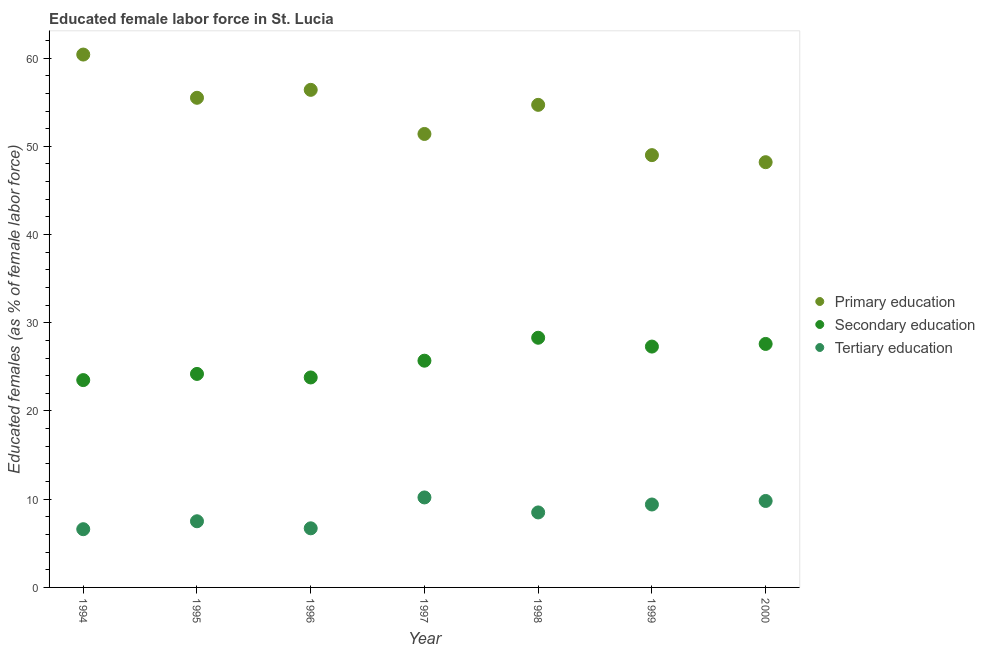How many different coloured dotlines are there?
Keep it short and to the point. 3. Across all years, what is the maximum percentage of female labor force who received secondary education?
Keep it short and to the point. 28.3. Across all years, what is the minimum percentage of female labor force who received secondary education?
Give a very brief answer. 23.5. In which year was the percentage of female labor force who received tertiary education maximum?
Provide a succinct answer. 1997. In which year was the percentage of female labor force who received secondary education minimum?
Your answer should be compact. 1994. What is the total percentage of female labor force who received secondary education in the graph?
Give a very brief answer. 180.4. What is the difference between the percentage of female labor force who received primary education in 1994 and that in 1995?
Offer a very short reply. 4.9. What is the difference between the percentage of female labor force who received secondary education in 1994 and the percentage of female labor force who received primary education in 1998?
Offer a terse response. -31.2. What is the average percentage of female labor force who received primary education per year?
Your response must be concise. 53.66. In the year 1995, what is the difference between the percentage of female labor force who received tertiary education and percentage of female labor force who received primary education?
Your response must be concise. -48. In how many years, is the percentage of female labor force who received tertiary education greater than 48 %?
Provide a short and direct response. 0. What is the ratio of the percentage of female labor force who received tertiary education in 1996 to that in 1998?
Provide a short and direct response. 0.79. Is the difference between the percentage of female labor force who received secondary education in 1995 and 1996 greater than the difference between the percentage of female labor force who received tertiary education in 1995 and 1996?
Give a very brief answer. No. What is the difference between the highest and the second highest percentage of female labor force who received primary education?
Your response must be concise. 4. What is the difference between the highest and the lowest percentage of female labor force who received tertiary education?
Provide a short and direct response. 3.6. In how many years, is the percentage of female labor force who received primary education greater than the average percentage of female labor force who received primary education taken over all years?
Keep it short and to the point. 4. How many years are there in the graph?
Provide a short and direct response. 7. What is the difference between two consecutive major ticks on the Y-axis?
Your answer should be very brief. 10. Are the values on the major ticks of Y-axis written in scientific E-notation?
Ensure brevity in your answer.  No. Does the graph contain any zero values?
Provide a succinct answer. No. Where does the legend appear in the graph?
Offer a very short reply. Center right. What is the title of the graph?
Give a very brief answer. Educated female labor force in St. Lucia. Does "Renewable sources" appear as one of the legend labels in the graph?
Ensure brevity in your answer.  No. What is the label or title of the Y-axis?
Your answer should be compact. Educated females (as % of female labor force). What is the Educated females (as % of female labor force) in Primary education in 1994?
Your answer should be very brief. 60.4. What is the Educated females (as % of female labor force) of Secondary education in 1994?
Keep it short and to the point. 23.5. What is the Educated females (as % of female labor force) of Tertiary education in 1994?
Provide a succinct answer. 6.6. What is the Educated females (as % of female labor force) in Primary education in 1995?
Your answer should be compact. 55.5. What is the Educated females (as % of female labor force) of Secondary education in 1995?
Offer a terse response. 24.2. What is the Educated females (as % of female labor force) of Tertiary education in 1995?
Ensure brevity in your answer.  7.5. What is the Educated females (as % of female labor force) in Primary education in 1996?
Your answer should be very brief. 56.4. What is the Educated females (as % of female labor force) of Secondary education in 1996?
Provide a short and direct response. 23.8. What is the Educated females (as % of female labor force) in Tertiary education in 1996?
Keep it short and to the point. 6.7. What is the Educated females (as % of female labor force) of Primary education in 1997?
Your response must be concise. 51.4. What is the Educated females (as % of female labor force) of Secondary education in 1997?
Provide a short and direct response. 25.7. What is the Educated females (as % of female labor force) in Tertiary education in 1997?
Offer a very short reply. 10.2. What is the Educated females (as % of female labor force) in Primary education in 1998?
Make the answer very short. 54.7. What is the Educated females (as % of female labor force) in Secondary education in 1998?
Offer a very short reply. 28.3. What is the Educated females (as % of female labor force) of Tertiary education in 1998?
Make the answer very short. 8.5. What is the Educated females (as % of female labor force) of Secondary education in 1999?
Provide a short and direct response. 27.3. What is the Educated females (as % of female labor force) of Tertiary education in 1999?
Offer a terse response. 9.4. What is the Educated females (as % of female labor force) of Primary education in 2000?
Keep it short and to the point. 48.2. What is the Educated females (as % of female labor force) of Secondary education in 2000?
Ensure brevity in your answer.  27.6. What is the Educated females (as % of female labor force) of Tertiary education in 2000?
Keep it short and to the point. 9.8. Across all years, what is the maximum Educated females (as % of female labor force) of Primary education?
Ensure brevity in your answer.  60.4. Across all years, what is the maximum Educated females (as % of female labor force) in Secondary education?
Ensure brevity in your answer.  28.3. Across all years, what is the maximum Educated females (as % of female labor force) in Tertiary education?
Ensure brevity in your answer.  10.2. Across all years, what is the minimum Educated females (as % of female labor force) in Primary education?
Keep it short and to the point. 48.2. Across all years, what is the minimum Educated females (as % of female labor force) in Tertiary education?
Offer a very short reply. 6.6. What is the total Educated females (as % of female labor force) of Primary education in the graph?
Ensure brevity in your answer.  375.6. What is the total Educated females (as % of female labor force) of Secondary education in the graph?
Give a very brief answer. 180.4. What is the total Educated females (as % of female labor force) of Tertiary education in the graph?
Keep it short and to the point. 58.7. What is the difference between the Educated females (as % of female labor force) of Tertiary education in 1994 and that in 1995?
Make the answer very short. -0.9. What is the difference between the Educated females (as % of female labor force) in Tertiary education in 1994 and that in 1996?
Keep it short and to the point. -0.1. What is the difference between the Educated females (as % of female labor force) in Tertiary education in 1994 and that in 1997?
Keep it short and to the point. -3.6. What is the difference between the Educated females (as % of female labor force) in Secondary education in 1994 and that in 1998?
Your answer should be very brief. -4.8. What is the difference between the Educated females (as % of female labor force) in Primary education in 1994 and that in 2000?
Your answer should be compact. 12.2. What is the difference between the Educated females (as % of female labor force) in Secondary education in 1994 and that in 2000?
Provide a short and direct response. -4.1. What is the difference between the Educated females (as % of female labor force) in Tertiary education in 1994 and that in 2000?
Make the answer very short. -3.2. What is the difference between the Educated females (as % of female labor force) in Tertiary education in 1995 and that in 1996?
Keep it short and to the point. 0.8. What is the difference between the Educated females (as % of female labor force) of Primary education in 1995 and that in 1997?
Make the answer very short. 4.1. What is the difference between the Educated females (as % of female labor force) of Primary education in 1995 and that in 1998?
Provide a short and direct response. 0.8. What is the difference between the Educated females (as % of female labor force) in Secondary education in 1995 and that in 1998?
Make the answer very short. -4.1. What is the difference between the Educated females (as % of female labor force) in Secondary education in 1995 and that in 1999?
Provide a succinct answer. -3.1. What is the difference between the Educated females (as % of female labor force) in Tertiary education in 1995 and that in 1999?
Offer a very short reply. -1.9. What is the difference between the Educated females (as % of female labor force) in Primary education in 1995 and that in 2000?
Offer a very short reply. 7.3. What is the difference between the Educated females (as % of female labor force) in Secondary education in 1996 and that in 1997?
Keep it short and to the point. -1.9. What is the difference between the Educated females (as % of female labor force) of Primary education in 1996 and that in 1998?
Offer a very short reply. 1.7. What is the difference between the Educated females (as % of female labor force) of Tertiary education in 1996 and that in 1998?
Give a very brief answer. -1.8. What is the difference between the Educated females (as % of female labor force) in Primary education in 1996 and that in 1999?
Ensure brevity in your answer.  7.4. What is the difference between the Educated females (as % of female labor force) in Secondary education in 1996 and that in 1999?
Keep it short and to the point. -3.5. What is the difference between the Educated females (as % of female labor force) of Tertiary education in 1996 and that in 1999?
Keep it short and to the point. -2.7. What is the difference between the Educated females (as % of female labor force) of Tertiary education in 1996 and that in 2000?
Your response must be concise. -3.1. What is the difference between the Educated females (as % of female labor force) of Primary education in 1997 and that in 1999?
Provide a succinct answer. 2.4. What is the difference between the Educated females (as % of female labor force) of Tertiary education in 1997 and that in 1999?
Offer a terse response. 0.8. What is the difference between the Educated females (as % of female labor force) in Primary education in 1997 and that in 2000?
Give a very brief answer. 3.2. What is the difference between the Educated females (as % of female labor force) in Secondary education in 1997 and that in 2000?
Make the answer very short. -1.9. What is the difference between the Educated females (as % of female labor force) of Primary education in 1998 and that in 1999?
Provide a short and direct response. 5.7. What is the difference between the Educated females (as % of female labor force) of Secondary education in 1998 and that in 2000?
Provide a succinct answer. 0.7. What is the difference between the Educated females (as % of female labor force) of Secondary education in 1999 and that in 2000?
Your answer should be very brief. -0.3. What is the difference between the Educated females (as % of female labor force) in Tertiary education in 1999 and that in 2000?
Keep it short and to the point. -0.4. What is the difference between the Educated females (as % of female labor force) in Primary education in 1994 and the Educated females (as % of female labor force) in Secondary education in 1995?
Offer a terse response. 36.2. What is the difference between the Educated females (as % of female labor force) in Primary education in 1994 and the Educated females (as % of female labor force) in Tertiary education in 1995?
Keep it short and to the point. 52.9. What is the difference between the Educated females (as % of female labor force) of Secondary education in 1994 and the Educated females (as % of female labor force) of Tertiary education in 1995?
Keep it short and to the point. 16. What is the difference between the Educated females (as % of female labor force) of Primary education in 1994 and the Educated females (as % of female labor force) of Secondary education in 1996?
Offer a terse response. 36.6. What is the difference between the Educated females (as % of female labor force) of Primary education in 1994 and the Educated females (as % of female labor force) of Tertiary education in 1996?
Provide a succinct answer. 53.7. What is the difference between the Educated females (as % of female labor force) of Primary education in 1994 and the Educated females (as % of female labor force) of Secondary education in 1997?
Provide a short and direct response. 34.7. What is the difference between the Educated females (as % of female labor force) in Primary education in 1994 and the Educated females (as % of female labor force) in Tertiary education in 1997?
Keep it short and to the point. 50.2. What is the difference between the Educated females (as % of female labor force) in Primary education in 1994 and the Educated females (as % of female labor force) in Secondary education in 1998?
Your answer should be compact. 32.1. What is the difference between the Educated females (as % of female labor force) of Primary education in 1994 and the Educated females (as % of female labor force) of Tertiary education in 1998?
Give a very brief answer. 51.9. What is the difference between the Educated females (as % of female labor force) of Secondary education in 1994 and the Educated females (as % of female labor force) of Tertiary education in 1998?
Offer a terse response. 15. What is the difference between the Educated females (as % of female labor force) in Primary education in 1994 and the Educated females (as % of female labor force) in Secondary education in 1999?
Keep it short and to the point. 33.1. What is the difference between the Educated females (as % of female labor force) in Primary education in 1994 and the Educated females (as % of female labor force) in Secondary education in 2000?
Offer a terse response. 32.8. What is the difference between the Educated females (as % of female labor force) of Primary education in 1994 and the Educated females (as % of female labor force) of Tertiary education in 2000?
Provide a succinct answer. 50.6. What is the difference between the Educated females (as % of female labor force) in Secondary education in 1994 and the Educated females (as % of female labor force) in Tertiary education in 2000?
Provide a succinct answer. 13.7. What is the difference between the Educated females (as % of female labor force) of Primary education in 1995 and the Educated females (as % of female labor force) of Secondary education in 1996?
Your answer should be compact. 31.7. What is the difference between the Educated females (as % of female labor force) in Primary education in 1995 and the Educated females (as % of female labor force) in Tertiary education in 1996?
Your response must be concise. 48.8. What is the difference between the Educated females (as % of female labor force) of Secondary education in 1995 and the Educated females (as % of female labor force) of Tertiary education in 1996?
Your answer should be very brief. 17.5. What is the difference between the Educated females (as % of female labor force) of Primary education in 1995 and the Educated females (as % of female labor force) of Secondary education in 1997?
Provide a short and direct response. 29.8. What is the difference between the Educated females (as % of female labor force) in Primary education in 1995 and the Educated females (as % of female labor force) in Tertiary education in 1997?
Give a very brief answer. 45.3. What is the difference between the Educated females (as % of female labor force) of Primary education in 1995 and the Educated females (as % of female labor force) of Secondary education in 1998?
Provide a short and direct response. 27.2. What is the difference between the Educated females (as % of female labor force) of Primary education in 1995 and the Educated females (as % of female labor force) of Tertiary education in 1998?
Keep it short and to the point. 47. What is the difference between the Educated females (as % of female labor force) in Secondary education in 1995 and the Educated females (as % of female labor force) in Tertiary education in 1998?
Your answer should be compact. 15.7. What is the difference between the Educated females (as % of female labor force) of Primary education in 1995 and the Educated females (as % of female labor force) of Secondary education in 1999?
Ensure brevity in your answer.  28.2. What is the difference between the Educated females (as % of female labor force) of Primary education in 1995 and the Educated females (as % of female labor force) of Tertiary education in 1999?
Offer a terse response. 46.1. What is the difference between the Educated females (as % of female labor force) of Secondary education in 1995 and the Educated females (as % of female labor force) of Tertiary education in 1999?
Keep it short and to the point. 14.8. What is the difference between the Educated females (as % of female labor force) of Primary education in 1995 and the Educated females (as % of female labor force) of Secondary education in 2000?
Ensure brevity in your answer.  27.9. What is the difference between the Educated females (as % of female labor force) in Primary education in 1995 and the Educated females (as % of female labor force) in Tertiary education in 2000?
Keep it short and to the point. 45.7. What is the difference between the Educated females (as % of female labor force) of Secondary education in 1995 and the Educated females (as % of female labor force) of Tertiary education in 2000?
Keep it short and to the point. 14.4. What is the difference between the Educated females (as % of female labor force) of Primary education in 1996 and the Educated females (as % of female labor force) of Secondary education in 1997?
Your answer should be very brief. 30.7. What is the difference between the Educated females (as % of female labor force) in Primary education in 1996 and the Educated females (as % of female labor force) in Tertiary education in 1997?
Make the answer very short. 46.2. What is the difference between the Educated females (as % of female labor force) of Secondary education in 1996 and the Educated females (as % of female labor force) of Tertiary education in 1997?
Provide a short and direct response. 13.6. What is the difference between the Educated females (as % of female labor force) in Primary education in 1996 and the Educated females (as % of female labor force) in Secondary education in 1998?
Ensure brevity in your answer.  28.1. What is the difference between the Educated females (as % of female labor force) of Primary education in 1996 and the Educated females (as % of female labor force) of Tertiary education in 1998?
Give a very brief answer. 47.9. What is the difference between the Educated females (as % of female labor force) of Primary education in 1996 and the Educated females (as % of female labor force) of Secondary education in 1999?
Offer a very short reply. 29.1. What is the difference between the Educated females (as % of female labor force) in Secondary education in 1996 and the Educated females (as % of female labor force) in Tertiary education in 1999?
Provide a short and direct response. 14.4. What is the difference between the Educated females (as % of female labor force) in Primary education in 1996 and the Educated females (as % of female labor force) in Secondary education in 2000?
Give a very brief answer. 28.8. What is the difference between the Educated females (as % of female labor force) of Primary education in 1996 and the Educated females (as % of female labor force) of Tertiary education in 2000?
Make the answer very short. 46.6. What is the difference between the Educated females (as % of female labor force) in Primary education in 1997 and the Educated females (as % of female labor force) in Secondary education in 1998?
Make the answer very short. 23.1. What is the difference between the Educated females (as % of female labor force) of Primary education in 1997 and the Educated females (as % of female labor force) of Tertiary education in 1998?
Provide a short and direct response. 42.9. What is the difference between the Educated females (as % of female labor force) in Secondary education in 1997 and the Educated females (as % of female labor force) in Tertiary education in 1998?
Ensure brevity in your answer.  17.2. What is the difference between the Educated females (as % of female labor force) in Primary education in 1997 and the Educated females (as % of female labor force) in Secondary education in 1999?
Keep it short and to the point. 24.1. What is the difference between the Educated females (as % of female labor force) of Primary education in 1997 and the Educated females (as % of female labor force) of Secondary education in 2000?
Your answer should be compact. 23.8. What is the difference between the Educated females (as % of female labor force) of Primary education in 1997 and the Educated females (as % of female labor force) of Tertiary education in 2000?
Provide a succinct answer. 41.6. What is the difference between the Educated females (as % of female labor force) of Secondary education in 1997 and the Educated females (as % of female labor force) of Tertiary education in 2000?
Your answer should be very brief. 15.9. What is the difference between the Educated females (as % of female labor force) in Primary education in 1998 and the Educated females (as % of female labor force) in Secondary education in 1999?
Your answer should be very brief. 27.4. What is the difference between the Educated females (as % of female labor force) of Primary education in 1998 and the Educated females (as % of female labor force) of Tertiary education in 1999?
Your response must be concise. 45.3. What is the difference between the Educated females (as % of female labor force) in Primary education in 1998 and the Educated females (as % of female labor force) in Secondary education in 2000?
Keep it short and to the point. 27.1. What is the difference between the Educated females (as % of female labor force) of Primary education in 1998 and the Educated females (as % of female labor force) of Tertiary education in 2000?
Your answer should be compact. 44.9. What is the difference between the Educated females (as % of female labor force) of Primary education in 1999 and the Educated females (as % of female labor force) of Secondary education in 2000?
Your answer should be very brief. 21.4. What is the difference between the Educated females (as % of female labor force) of Primary education in 1999 and the Educated females (as % of female labor force) of Tertiary education in 2000?
Keep it short and to the point. 39.2. What is the difference between the Educated females (as % of female labor force) of Secondary education in 1999 and the Educated females (as % of female labor force) of Tertiary education in 2000?
Give a very brief answer. 17.5. What is the average Educated females (as % of female labor force) of Primary education per year?
Provide a short and direct response. 53.66. What is the average Educated females (as % of female labor force) in Secondary education per year?
Your response must be concise. 25.77. What is the average Educated females (as % of female labor force) of Tertiary education per year?
Your answer should be very brief. 8.39. In the year 1994, what is the difference between the Educated females (as % of female labor force) in Primary education and Educated females (as % of female labor force) in Secondary education?
Your response must be concise. 36.9. In the year 1994, what is the difference between the Educated females (as % of female labor force) in Primary education and Educated females (as % of female labor force) in Tertiary education?
Offer a terse response. 53.8. In the year 1994, what is the difference between the Educated females (as % of female labor force) in Secondary education and Educated females (as % of female labor force) in Tertiary education?
Offer a terse response. 16.9. In the year 1995, what is the difference between the Educated females (as % of female labor force) of Primary education and Educated females (as % of female labor force) of Secondary education?
Your answer should be very brief. 31.3. In the year 1995, what is the difference between the Educated females (as % of female labor force) in Primary education and Educated females (as % of female labor force) in Tertiary education?
Your answer should be compact. 48. In the year 1996, what is the difference between the Educated females (as % of female labor force) in Primary education and Educated females (as % of female labor force) in Secondary education?
Your answer should be very brief. 32.6. In the year 1996, what is the difference between the Educated females (as % of female labor force) of Primary education and Educated females (as % of female labor force) of Tertiary education?
Keep it short and to the point. 49.7. In the year 1996, what is the difference between the Educated females (as % of female labor force) in Secondary education and Educated females (as % of female labor force) in Tertiary education?
Give a very brief answer. 17.1. In the year 1997, what is the difference between the Educated females (as % of female labor force) of Primary education and Educated females (as % of female labor force) of Secondary education?
Ensure brevity in your answer.  25.7. In the year 1997, what is the difference between the Educated females (as % of female labor force) in Primary education and Educated females (as % of female labor force) in Tertiary education?
Provide a short and direct response. 41.2. In the year 1997, what is the difference between the Educated females (as % of female labor force) in Secondary education and Educated females (as % of female labor force) in Tertiary education?
Keep it short and to the point. 15.5. In the year 1998, what is the difference between the Educated females (as % of female labor force) of Primary education and Educated females (as % of female labor force) of Secondary education?
Provide a succinct answer. 26.4. In the year 1998, what is the difference between the Educated females (as % of female labor force) in Primary education and Educated females (as % of female labor force) in Tertiary education?
Your answer should be very brief. 46.2. In the year 1998, what is the difference between the Educated females (as % of female labor force) in Secondary education and Educated females (as % of female labor force) in Tertiary education?
Ensure brevity in your answer.  19.8. In the year 1999, what is the difference between the Educated females (as % of female labor force) of Primary education and Educated females (as % of female labor force) of Secondary education?
Make the answer very short. 21.7. In the year 1999, what is the difference between the Educated females (as % of female labor force) in Primary education and Educated females (as % of female labor force) in Tertiary education?
Offer a terse response. 39.6. In the year 1999, what is the difference between the Educated females (as % of female labor force) of Secondary education and Educated females (as % of female labor force) of Tertiary education?
Your answer should be very brief. 17.9. In the year 2000, what is the difference between the Educated females (as % of female labor force) of Primary education and Educated females (as % of female labor force) of Secondary education?
Make the answer very short. 20.6. In the year 2000, what is the difference between the Educated females (as % of female labor force) of Primary education and Educated females (as % of female labor force) of Tertiary education?
Your answer should be very brief. 38.4. In the year 2000, what is the difference between the Educated females (as % of female labor force) of Secondary education and Educated females (as % of female labor force) of Tertiary education?
Your answer should be compact. 17.8. What is the ratio of the Educated females (as % of female labor force) in Primary education in 1994 to that in 1995?
Offer a very short reply. 1.09. What is the ratio of the Educated females (as % of female labor force) of Secondary education in 1994 to that in 1995?
Offer a terse response. 0.97. What is the ratio of the Educated females (as % of female labor force) in Tertiary education in 1994 to that in 1995?
Your answer should be very brief. 0.88. What is the ratio of the Educated females (as % of female labor force) of Primary education in 1994 to that in 1996?
Provide a succinct answer. 1.07. What is the ratio of the Educated females (as % of female labor force) in Secondary education in 1994 to that in 1996?
Provide a succinct answer. 0.99. What is the ratio of the Educated females (as % of female labor force) in Tertiary education in 1994 to that in 1996?
Make the answer very short. 0.99. What is the ratio of the Educated females (as % of female labor force) in Primary education in 1994 to that in 1997?
Your answer should be very brief. 1.18. What is the ratio of the Educated females (as % of female labor force) of Secondary education in 1994 to that in 1997?
Offer a very short reply. 0.91. What is the ratio of the Educated females (as % of female labor force) in Tertiary education in 1994 to that in 1997?
Your response must be concise. 0.65. What is the ratio of the Educated females (as % of female labor force) in Primary education in 1994 to that in 1998?
Ensure brevity in your answer.  1.1. What is the ratio of the Educated females (as % of female labor force) in Secondary education in 1994 to that in 1998?
Provide a short and direct response. 0.83. What is the ratio of the Educated females (as % of female labor force) in Tertiary education in 1994 to that in 1998?
Make the answer very short. 0.78. What is the ratio of the Educated females (as % of female labor force) of Primary education in 1994 to that in 1999?
Give a very brief answer. 1.23. What is the ratio of the Educated females (as % of female labor force) of Secondary education in 1994 to that in 1999?
Give a very brief answer. 0.86. What is the ratio of the Educated females (as % of female labor force) in Tertiary education in 1994 to that in 1999?
Provide a short and direct response. 0.7. What is the ratio of the Educated females (as % of female labor force) in Primary education in 1994 to that in 2000?
Offer a very short reply. 1.25. What is the ratio of the Educated females (as % of female labor force) of Secondary education in 1994 to that in 2000?
Your response must be concise. 0.85. What is the ratio of the Educated females (as % of female labor force) in Tertiary education in 1994 to that in 2000?
Offer a terse response. 0.67. What is the ratio of the Educated females (as % of female labor force) of Primary education in 1995 to that in 1996?
Ensure brevity in your answer.  0.98. What is the ratio of the Educated females (as % of female labor force) in Secondary education in 1995 to that in 1996?
Keep it short and to the point. 1.02. What is the ratio of the Educated females (as % of female labor force) in Tertiary education in 1995 to that in 1996?
Your response must be concise. 1.12. What is the ratio of the Educated females (as % of female labor force) in Primary education in 1995 to that in 1997?
Give a very brief answer. 1.08. What is the ratio of the Educated females (as % of female labor force) in Secondary education in 1995 to that in 1997?
Your response must be concise. 0.94. What is the ratio of the Educated females (as % of female labor force) of Tertiary education in 1995 to that in 1997?
Offer a very short reply. 0.74. What is the ratio of the Educated females (as % of female labor force) of Primary education in 1995 to that in 1998?
Your answer should be compact. 1.01. What is the ratio of the Educated females (as % of female labor force) of Secondary education in 1995 to that in 1998?
Your answer should be very brief. 0.86. What is the ratio of the Educated females (as % of female labor force) of Tertiary education in 1995 to that in 1998?
Offer a very short reply. 0.88. What is the ratio of the Educated females (as % of female labor force) in Primary education in 1995 to that in 1999?
Offer a terse response. 1.13. What is the ratio of the Educated females (as % of female labor force) in Secondary education in 1995 to that in 1999?
Make the answer very short. 0.89. What is the ratio of the Educated females (as % of female labor force) in Tertiary education in 1995 to that in 1999?
Your response must be concise. 0.8. What is the ratio of the Educated females (as % of female labor force) in Primary education in 1995 to that in 2000?
Offer a terse response. 1.15. What is the ratio of the Educated females (as % of female labor force) of Secondary education in 1995 to that in 2000?
Provide a short and direct response. 0.88. What is the ratio of the Educated females (as % of female labor force) of Tertiary education in 1995 to that in 2000?
Your answer should be very brief. 0.77. What is the ratio of the Educated females (as % of female labor force) of Primary education in 1996 to that in 1997?
Provide a short and direct response. 1.1. What is the ratio of the Educated females (as % of female labor force) of Secondary education in 1996 to that in 1997?
Your answer should be compact. 0.93. What is the ratio of the Educated females (as % of female labor force) in Tertiary education in 1996 to that in 1997?
Ensure brevity in your answer.  0.66. What is the ratio of the Educated females (as % of female labor force) in Primary education in 1996 to that in 1998?
Ensure brevity in your answer.  1.03. What is the ratio of the Educated females (as % of female labor force) in Secondary education in 1996 to that in 1998?
Offer a very short reply. 0.84. What is the ratio of the Educated females (as % of female labor force) in Tertiary education in 1996 to that in 1998?
Ensure brevity in your answer.  0.79. What is the ratio of the Educated females (as % of female labor force) of Primary education in 1996 to that in 1999?
Your answer should be very brief. 1.15. What is the ratio of the Educated females (as % of female labor force) of Secondary education in 1996 to that in 1999?
Offer a very short reply. 0.87. What is the ratio of the Educated females (as % of female labor force) of Tertiary education in 1996 to that in 1999?
Ensure brevity in your answer.  0.71. What is the ratio of the Educated females (as % of female labor force) in Primary education in 1996 to that in 2000?
Your answer should be compact. 1.17. What is the ratio of the Educated females (as % of female labor force) of Secondary education in 1996 to that in 2000?
Offer a terse response. 0.86. What is the ratio of the Educated females (as % of female labor force) in Tertiary education in 1996 to that in 2000?
Provide a succinct answer. 0.68. What is the ratio of the Educated females (as % of female labor force) in Primary education in 1997 to that in 1998?
Ensure brevity in your answer.  0.94. What is the ratio of the Educated females (as % of female labor force) in Secondary education in 1997 to that in 1998?
Ensure brevity in your answer.  0.91. What is the ratio of the Educated females (as % of female labor force) of Primary education in 1997 to that in 1999?
Your answer should be compact. 1.05. What is the ratio of the Educated females (as % of female labor force) of Secondary education in 1997 to that in 1999?
Keep it short and to the point. 0.94. What is the ratio of the Educated females (as % of female labor force) of Tertiary education in 1997 to that in 1999?
Ensure brevity in your answer.  1.09. What is the ratio of the Educated females (as % of female labor force) of Primary education in 1997 to that in 2000?
Your response must be concise. 1.07. What is the ratio of the Educated females (as % of female labor force) in Secondary education in 1997 to that in 2000?
Provide a succinct answer. 0.93. What is the ratio of the Educated females (as % of female labor force) in Tertiary education in 1997 to that in 2000?
Give a very brief answer. 1.04. What is the ratio of the Educated females (as % of female labor force) in Primary education in 1998 to that in 1999?
Make the answer very short. 1.12. What is the ratio of the Educated females (as % of female labor force) of Secondary education in 1998 to that in 1999?
Your response must be concise. 1.04. What is the ratio of the Educated females (as % of female labor force) of Tertiary education in 1998 to that in 1999?
Your answer should be very brief. 0.9. What is the ratio of the Educated females (as % of female labor force) in Primary education in 1998 to that in 2000?
Provide a short and direct response. 1.13. What is the ratio of the Educated females (as % of female labor force) in Secondary education in 1998 to that in 2000?
Keep it short and to the point. 1.03. What is the ratio of the Educated females (as % of female labor force) in Tertiary education in 1998 to that in 2000?
Offer a very short reply. 0.87. What is the ratio of the Educated females (as % of female labor force) in Primary education in 1999 to that in 2000?
Provide a succinct answer. 1.02. What is the ratio of the Educated females (as % of female labor force) in Secondary education in 1999 to that in 2000?
Offer a terse response. 0.99. What is the ratio of the Educated females (as % of female labor force) in Tertiary education in 1999 to that in 2000?
Offer a very short reply. 0.96. What is the difference between the highest and the lowest Educated females (as % of female labor force) of Secondary education?
Make the answer very short. 4.8. What is the difference between the highest and the lowest Educated females (as % of female labor force) in Tertiary education?
Your answer should be very brief. 3.6. 